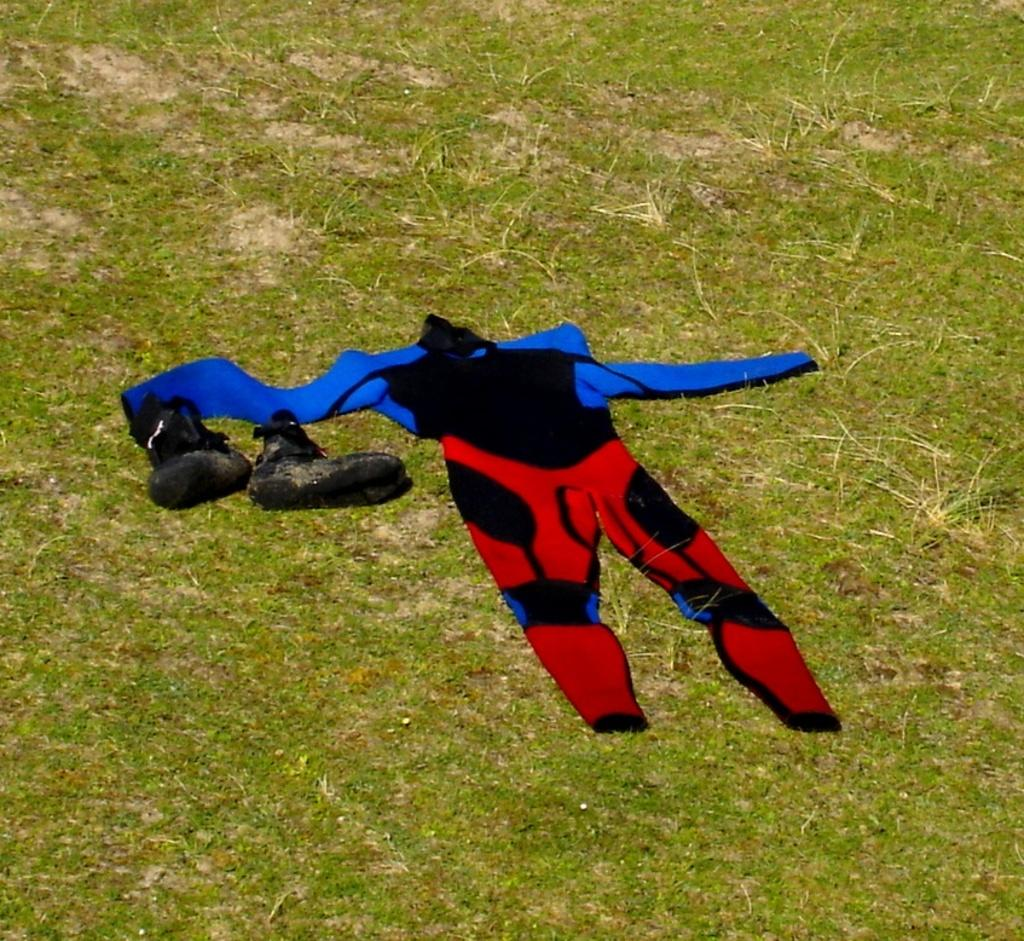What type of clothing is in the image? There is a dress in the image. What colors can be seen on the dress? The dress has blue, black, and red colors. What type of footwear is visible in the image? There are black color shoes in the image. Where are the shoes located in the image? The shoes are on the grass. How many apples are stitched onto the dress in the image? There are no apples present on the dress in the image. What is the wish of the person wearing the dress in the image? There is no information about the person wearing the dress or their wishes in the image. 